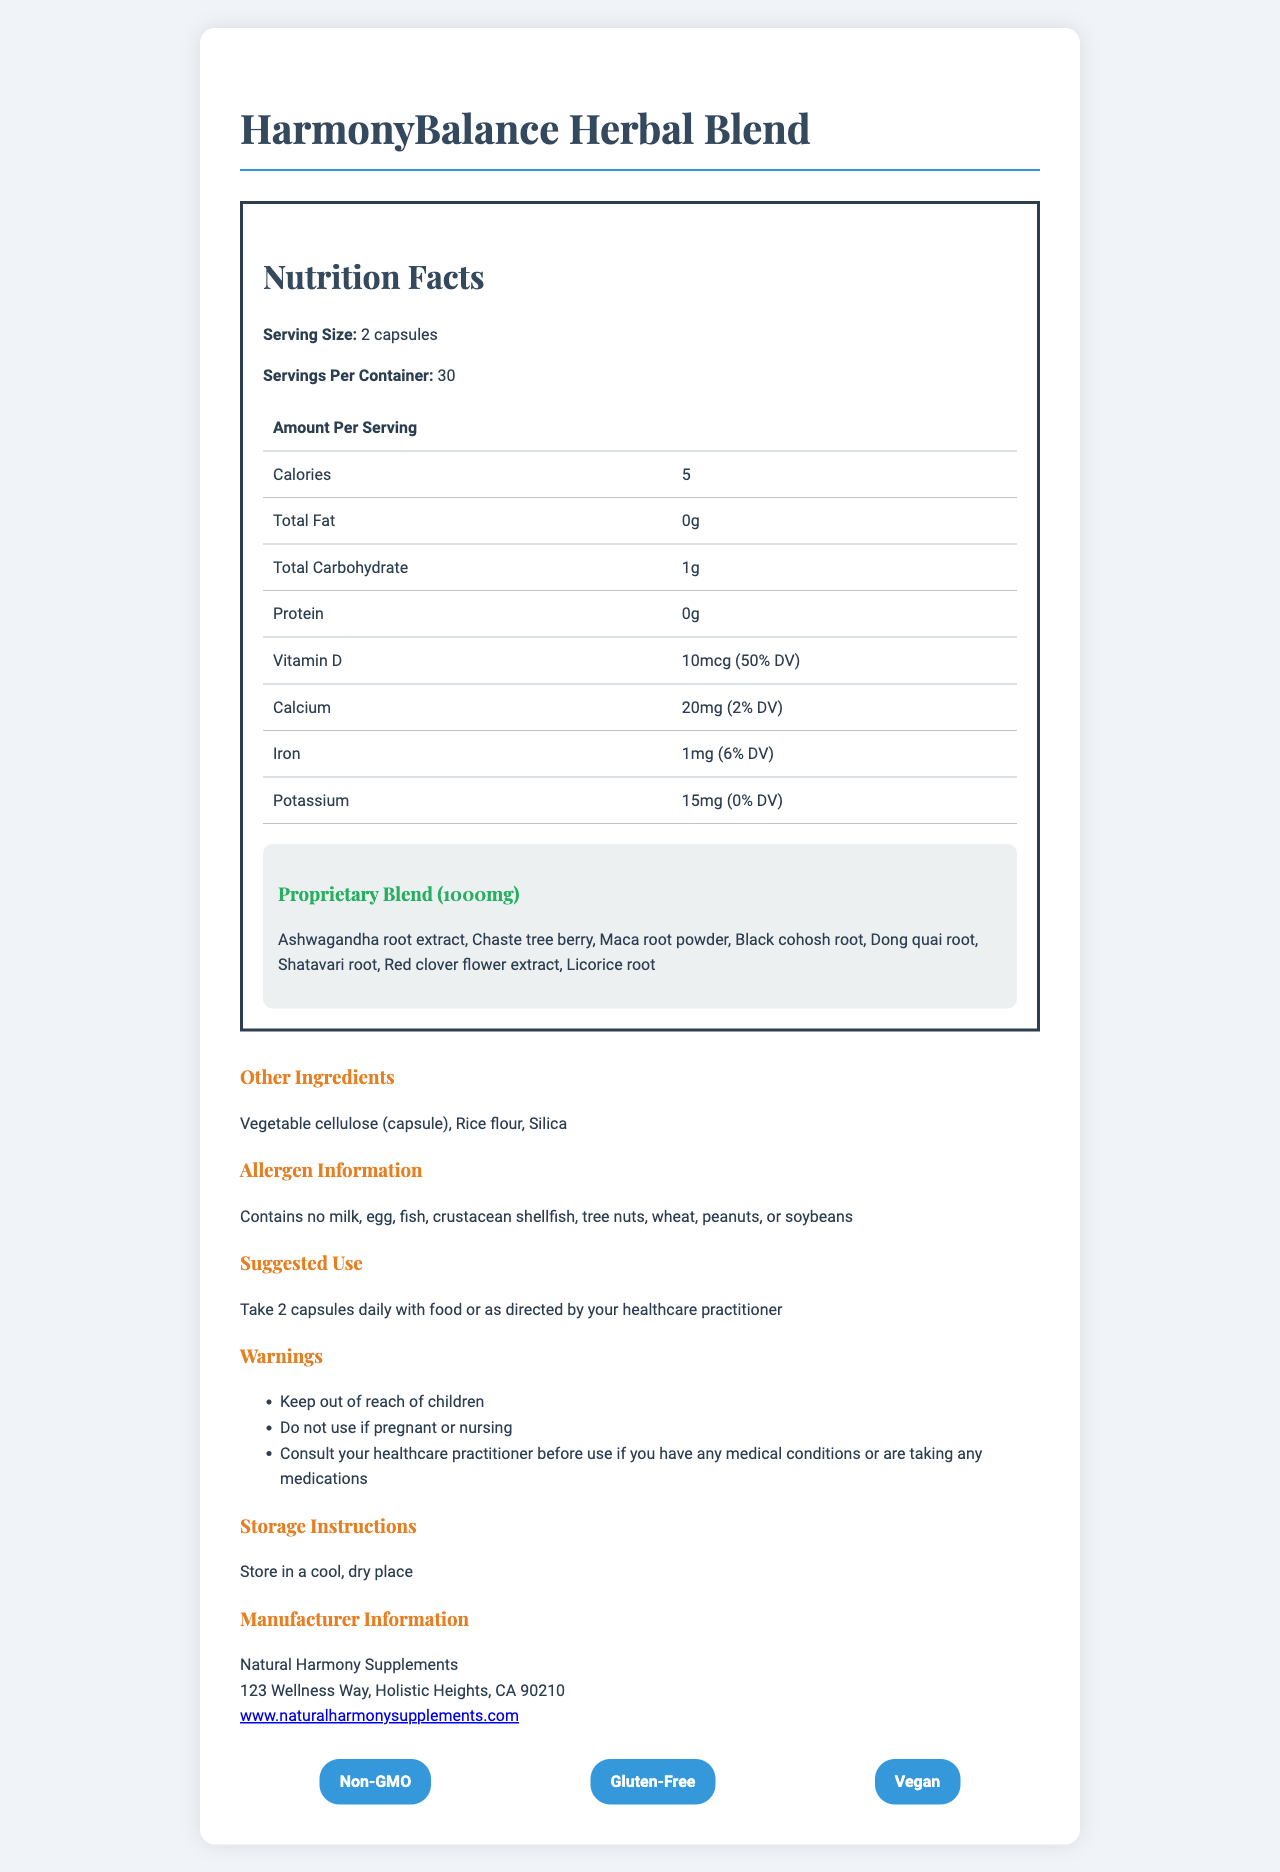what is the serving size for HarmonyBalance Herbal Blend? The document states that the serving size for the supplement is 2 capsules.
Answer: 2 capsules how many calories are in each serving? The document lists the calories per serving as 5.
Answer: 5 calories what is the total carbohydrate content per serving? According to the document, the total carbohydrate per serving is 1 gram.
Answer: 1g what is the percentage daily value (%DV) of Vitamin D per serving? The document indicates that the Vitamin D content per serving provides 50% of the daily value.
Answer: 50% how many servings are in the container? The document specifies that there are 30 servings per container.
Answer: 30 servings which ingredient is not part of the proprietary blend? A. Ashwagandha root extract B. Chaste tree berry C. Rice flour D. Licorice root The proprietary blend includes ingredients like Ashwagandha root extract, Chaste tree berry, and Licorice root. Rice flour is listed as an "Other Ingredient".
Answer: C. Rice flour what is the main ingredient used for the capsules? A. Silica B. Rice flour C. Vegetable cellulose D. Licorice root The document lists vegetable cellulose as the primary material for the capsule.
Answer: C. Vegetable cellulose are there any allergens present in the supplement? The document states that the supplement contains no milk, egg, fish, crustacean shellfish, tree nuts, wheat, peanuts, or soybeans.
Answer: No is this herbal blend suitable for vegans? The supplement is labeled as Vegan, which means it is suitable for individuals following a vegan diet.
Answer: Yes summarize the overall use and benefits of the HarmonyBalance Herbal Blend This summary captures the essential details about the usage, composition, suggested use, and suitability for different dietary preferences.
Answer: The HarmonyBalance Herbal Blend is designed to provide a holistic approach to hormone regulation. It includes a proprietary blend of several herbal ingredients known for their hormone-balancing properties, such as Ashwagandha, Chaste tree berry, and Maca root powder. The supplement is vegan, non-GMO, and gluten-free, with each serving containing calories, carbohydrates, and essential vitamins like Vitamin D, calcium, and iron. The suggested use is 2 capsules daily with food, and it includes warnings for certain groups like children, pregnant or nursing women, and individuals with medical conditions. is this supplement gluten-free? The document lists "Gluten-Free" as one of the certifications, indicating that this supplement is gluten-free.
Answer: Yes what is the total weight of the proprietary blend per serving? The document states that the proprietary blend weighs 1000mg per serving.
Answer: 1000mg can this supplement be used by pregnant women? The document includes a warning that it should not be used by pregnant or nursing women.
Answer: No what is the manufacturer’s website? The document lists the manufacturer's website as www.naturalharmonysupplements.com.
Answer: www.naturalharmonysupplements.com what percentage of the daily value of calcium does each serving provide? The document indicates that each serving provides 2% of the daily value of calcium.
Answer: 2% identify one warning mentioned for using this supplement. The document advises to keep the supplement out of reach of children.
Answer: Keep out of reach of children. how should the HarmonyBalance Herbal Blend be stored? The storage instructions in the document specify to store the supplement in a cool, dry place.
Answer: Store in a cool, dry place. what is the address of the manufacturer? The document lists the manufacturer's address as 123 Wellness Way, Holistic Heights, CA 90210.
Answer: 123 Wellness Way, Holistic Heights, CA 90210 does the supplement contain potassium? The document indicates that each serving contains 15mg of potassium, which is 0% DV.
Answer: Yes what are the health benefits of Maca root powder in the proprietary blend? The document lists Maca root powder as part of the proprietary blend but does not provide specific health benefits.
Answer: Not enough information 